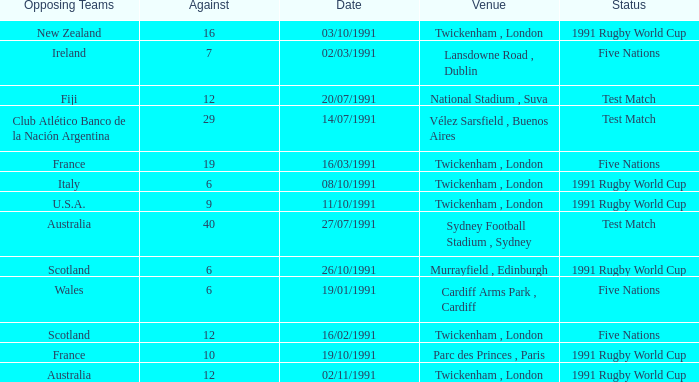What is Opposing Teams, when Date is "11/10/1991"? U.S.A. 